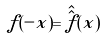Convert formula to latex. <formula><loc_0><loc_0><loc_500><loc_500>f ( - x ) = \hat { \hat { f } } ( x )</formula> 